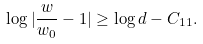Convert formula to latex. <formula><loc_0><loc_0><loc_500><loc_500>\log | \frac { w } { w _ { 0 } } - 1 | \geq \log d - C _ { 1 1 } .</formula> 